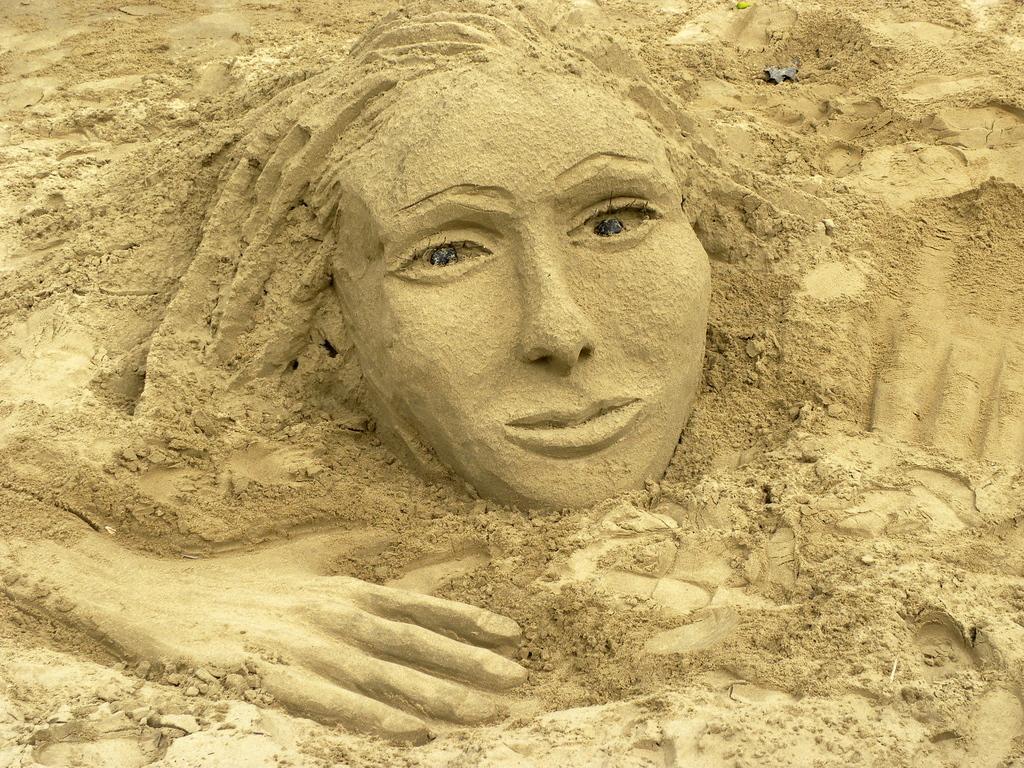Please provide a concise description of this image. In this picture we can see sand art. 